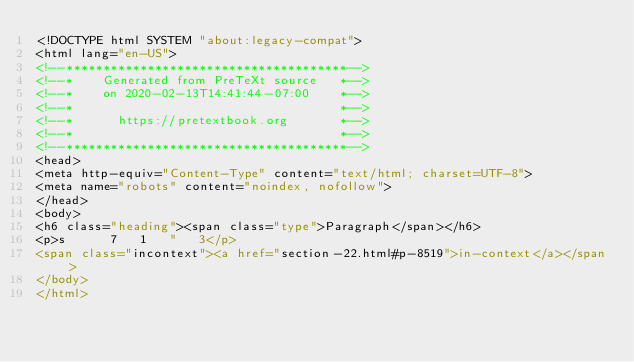Convert code to text. <code><loc_0><loc_0><loc_500><loc_500><_HTML_><!DOCTYPE html SYSTEM "about:legacy-compat">
<html lang="en-US">
<!--**************************************-->
<!--*    Generated from PreTeXt source   *-->
<!--*    on 2020-02-13T14:41:44-07:00    *-->
<!--*                                    *-->
<!--*      https://pretextbook.org       *-->
<!--*                                    *-->
<!--**************************************-->
<head>
<meta http-equiv="Content-Type" content="text/html; charset=UTF-8">
<meta name="robots" content="noindex, nofollow">
</head>
<body>
<h6 class="heading"><span class="type">Paragraph</span></h6>
<p>s      7   1   "   3</p>
<span class="incontext"><a href="section-22.html#p-8519">in-context</a></span>
</body>
</html>
</code> 